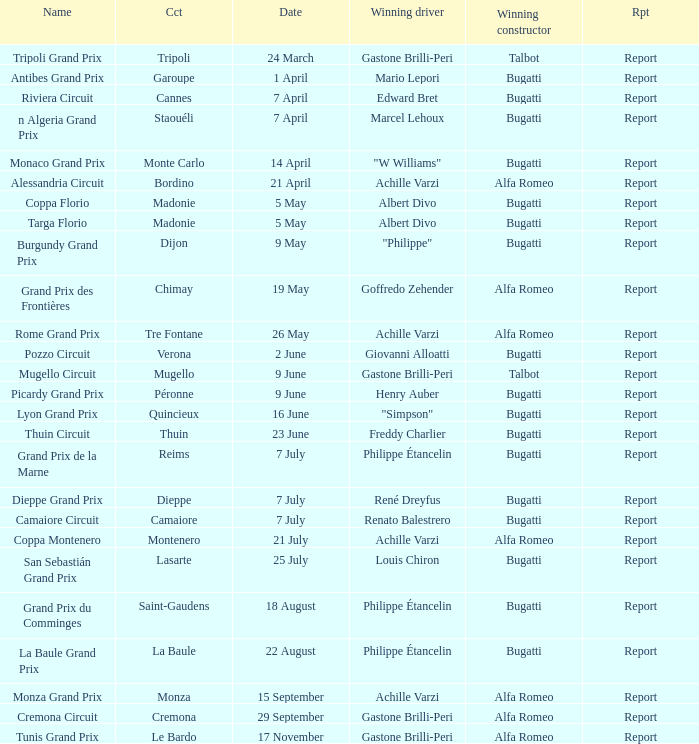What Name has a Winning constructor of bugatti, and a Winning driver of louis chiron? San Sebastián Grand Prix. 